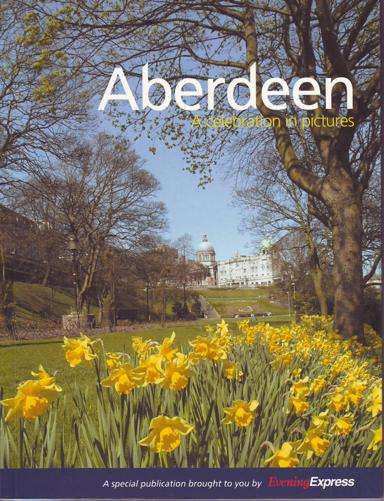What is the significance of the building featured prominently in the background of the image? The building prominently featured in the background is Marischal College, which is one of the key landmarks in Aberdeen. It is the second-largest granite building in the world and serves as the headquarters of Aberdeen City Council. This majestic structure symbolizes Aberdeen's rich academic and architectural heritage. 